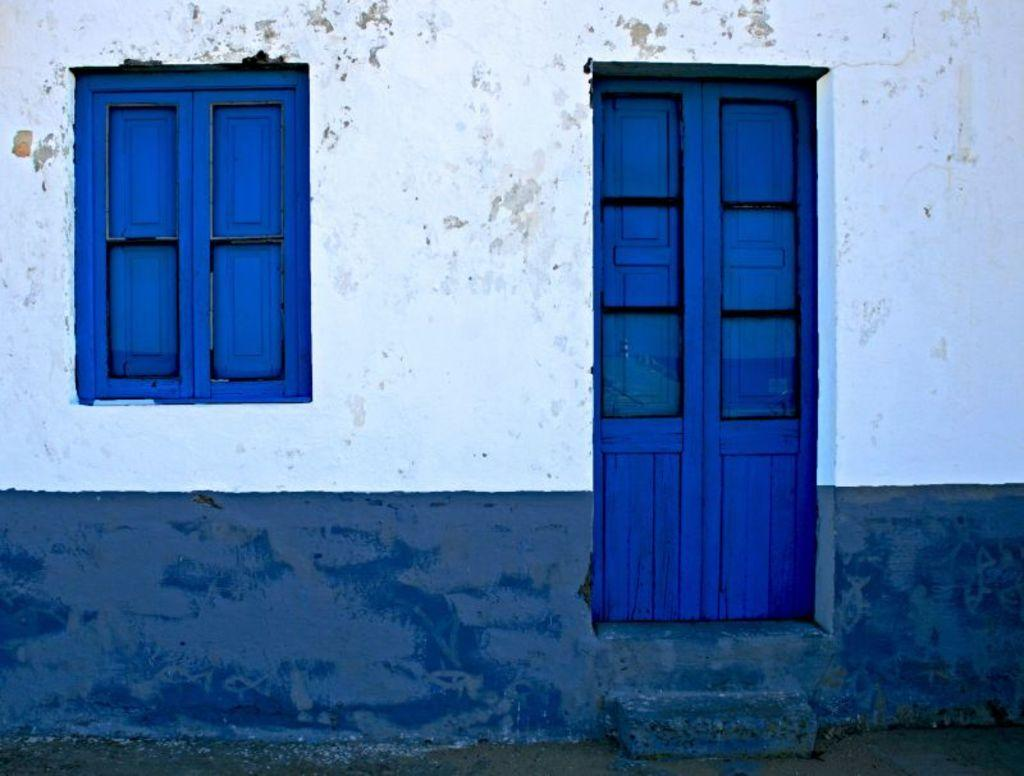What colors are used on the wall in the image? The wall in the image is white and blue in color. What is the color of the windows in the image? The windows in the image are blue in color. What is the color of the doors in the image? The doors in the image are blue in color. How does the wall stretch in the image? The wall does not stretch in the image; it is a static structure. 